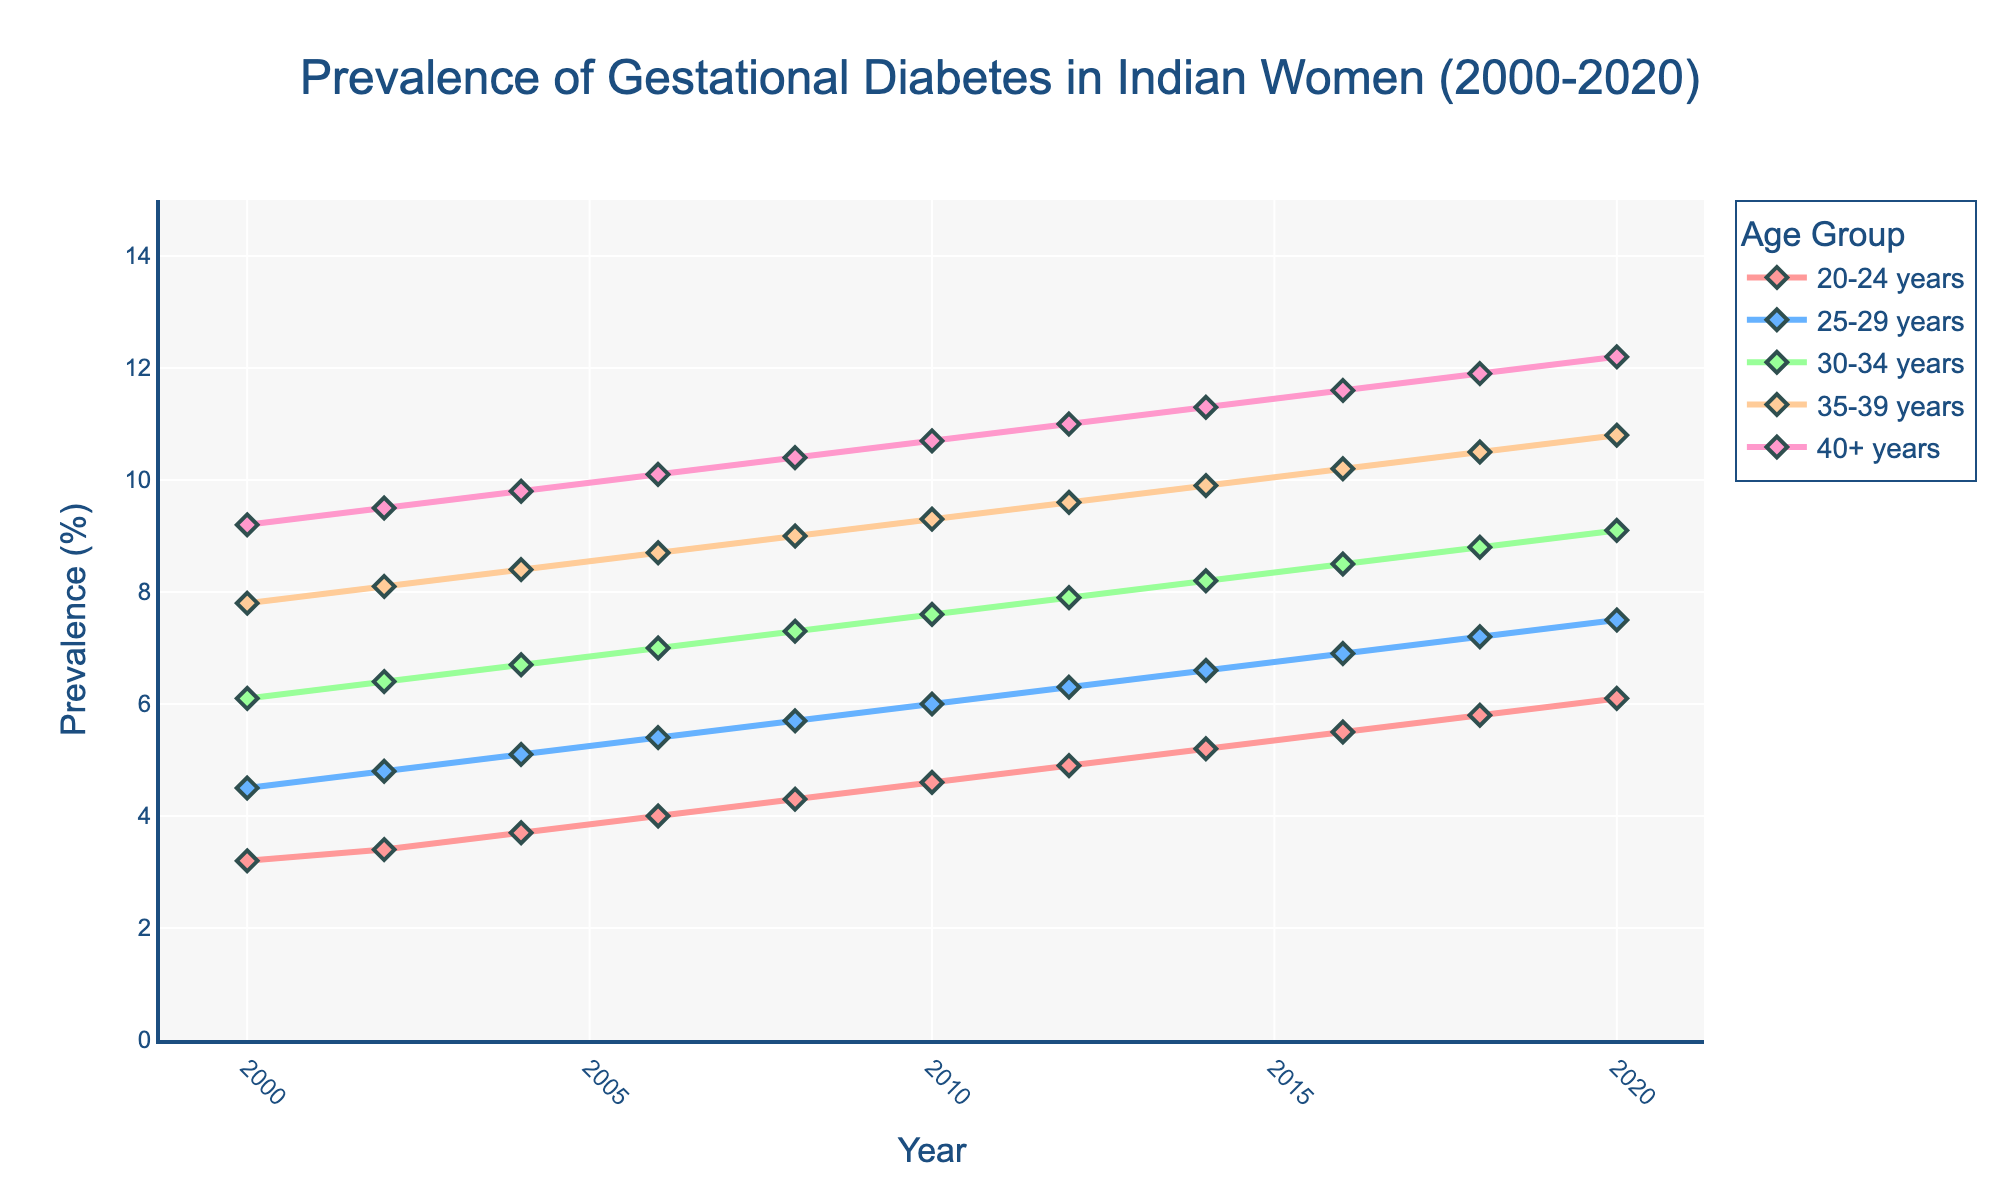What was the prevalence of gestational diabetes in women aged 25-29 years in 2010? Look at the data point for the year 2010 in the line corresponding to the 25-29 years age group.
Answer: 6.0% Which age group saw the highest increase in the prevalence of gestational diabetes from 2000 to 2020? Calculate the difference between 2020 and 2000 prevalence values for each age group and compare them. For 20-24 years: 6.1 - 3.2 = 2.9, For 25-29 years: 7.5 - 4.5 = 3.0, For 30-34 years: 9.1 - 6.1 = 3.0, For 35-39 years: 10.8 - 7.8 = 3.0, For 40+ years: 12.2 - 9.2 = 3.0. All age groups have the same increase, thus none stands out.
Answer: All groups have the same increase Did the prevalence of gestational diabetes increase steadily in each age group over the two decades? Check if each line for every age group shows a consistent upward trend from 2000 to 2020 without any dips. Yes, all lines increase steadily without any drops.
Answer: Yes In which year did women aged 30-34 years experience a prevalence rate higher than 7.5% for the first time? Track the year from the data points for the 30-34 years age group where the value exceeds 7.5% for the first time.
Answer: 2010 How much did the prevalence rate increase for the age group 20-24 years from 2010 to 2020? Subtract the prevalence rate for 20-24 years in 2010 from the rate in 2020: 6.1 - 4.6.
Answer: 1.5% Which age group had the highest prevalence of gestational diabetes in 2008? Check the prevalence values for all age groups in the year 2008 and identify the highest one.
Answer: 40+ years What is the average prevalence of gestational diabetes in women aged 35-39 years over the two decades? Calculate the average of the prevalence values from 2000 to 2020 for the 35-39 years age group: (7.8 + 8.1 + 8.4 + 8.7 + 9.0 + 9.3 + 9.6 + 9.9 + 10.2 + 10.5 + 10.8) / 11 ≈ 9.07.
Answer: 9.07% Compare the prevalence rates of gestational diabetes of women aged 40+ years in 2004 and 2016. Look at the data points for the year 2004 and 2016 in the 40+ years age group. For 2004: 9.8%, for 2016: 11.6%. Check which one is higher.
Answer: 2016 is higher What is the overall trend in the prevalence of gestational diabetes for women aged 20-24 years from 2000 to 2020? Track the entire trend of data points from 2000 to 2020 for the 20-24 years age group and describe the pattern observed. The pattern shows a consistently increasing trend.
Answer: Increasing 